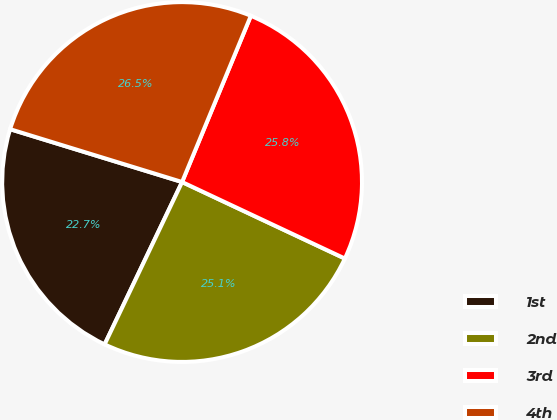Convert chart. <chart><loc_0><loc_0><loc_500><loc_500><pie_chart><fcel>1st<fcel>2nd<fcel>3rd<fcel>4th<nl><fcel>22.66%<fcel>25.09%<fcel>25.75%<fcel>26.5%<nl></chart> 